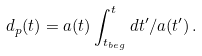<formula> <loc_0><loc_0><loc_500><loc_500>d _ { p } ( t ) = a ( t ) \int _ { t _ { b e g } } ^ { t } d t ^ { \prime } / a ( t ^ { \prime } ) \, .</formula> 